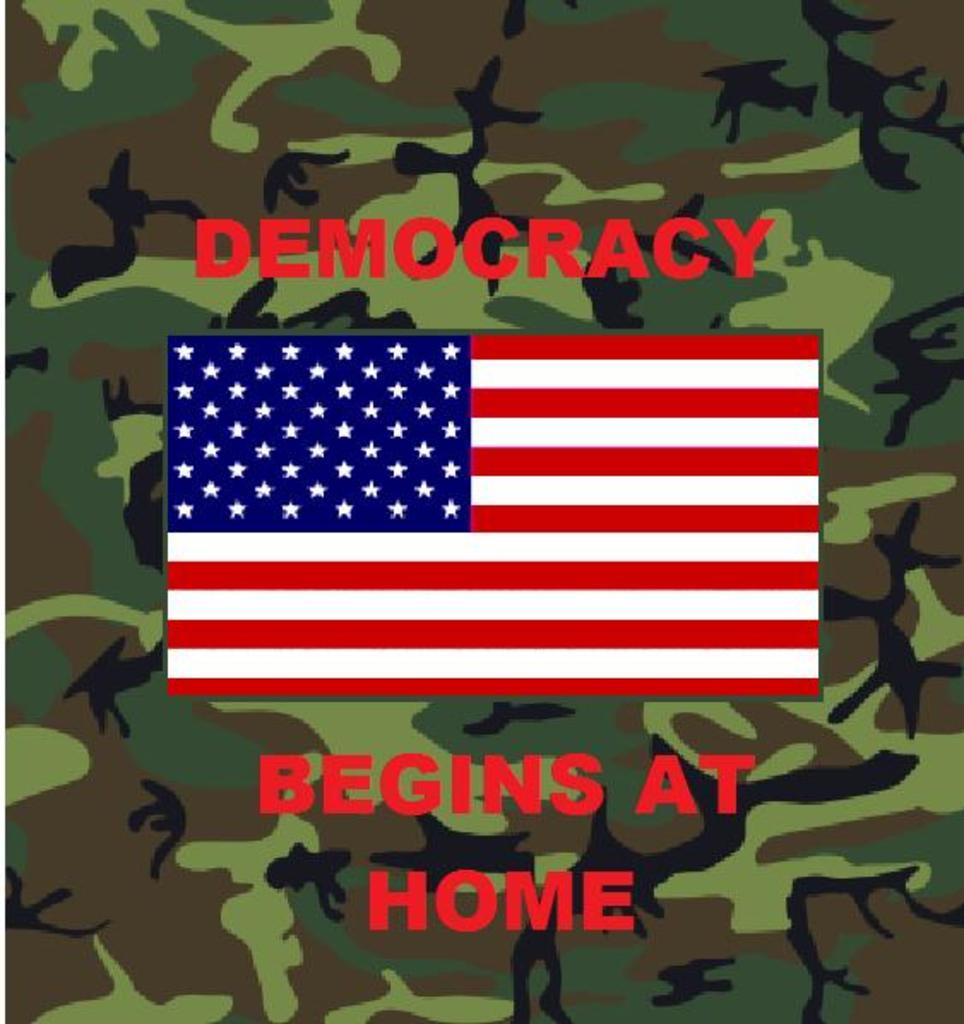What is the main subject in the middle of the image? There is a flag in the middle of the image. What can be seen at the top of the image? There is text on the top of the image. What can be seen at the bottom of the image? There is text on the bottom of the image. How many rooms are visible in the image? There is no room visible in the image; it features a flag and text. What type of transportation station can be seen in the image? There is no transportation station present in the image. 